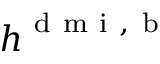<formula> <loc_0><loc_0><loc_500><loc_500>h ^ { d m i , b }</formula> 